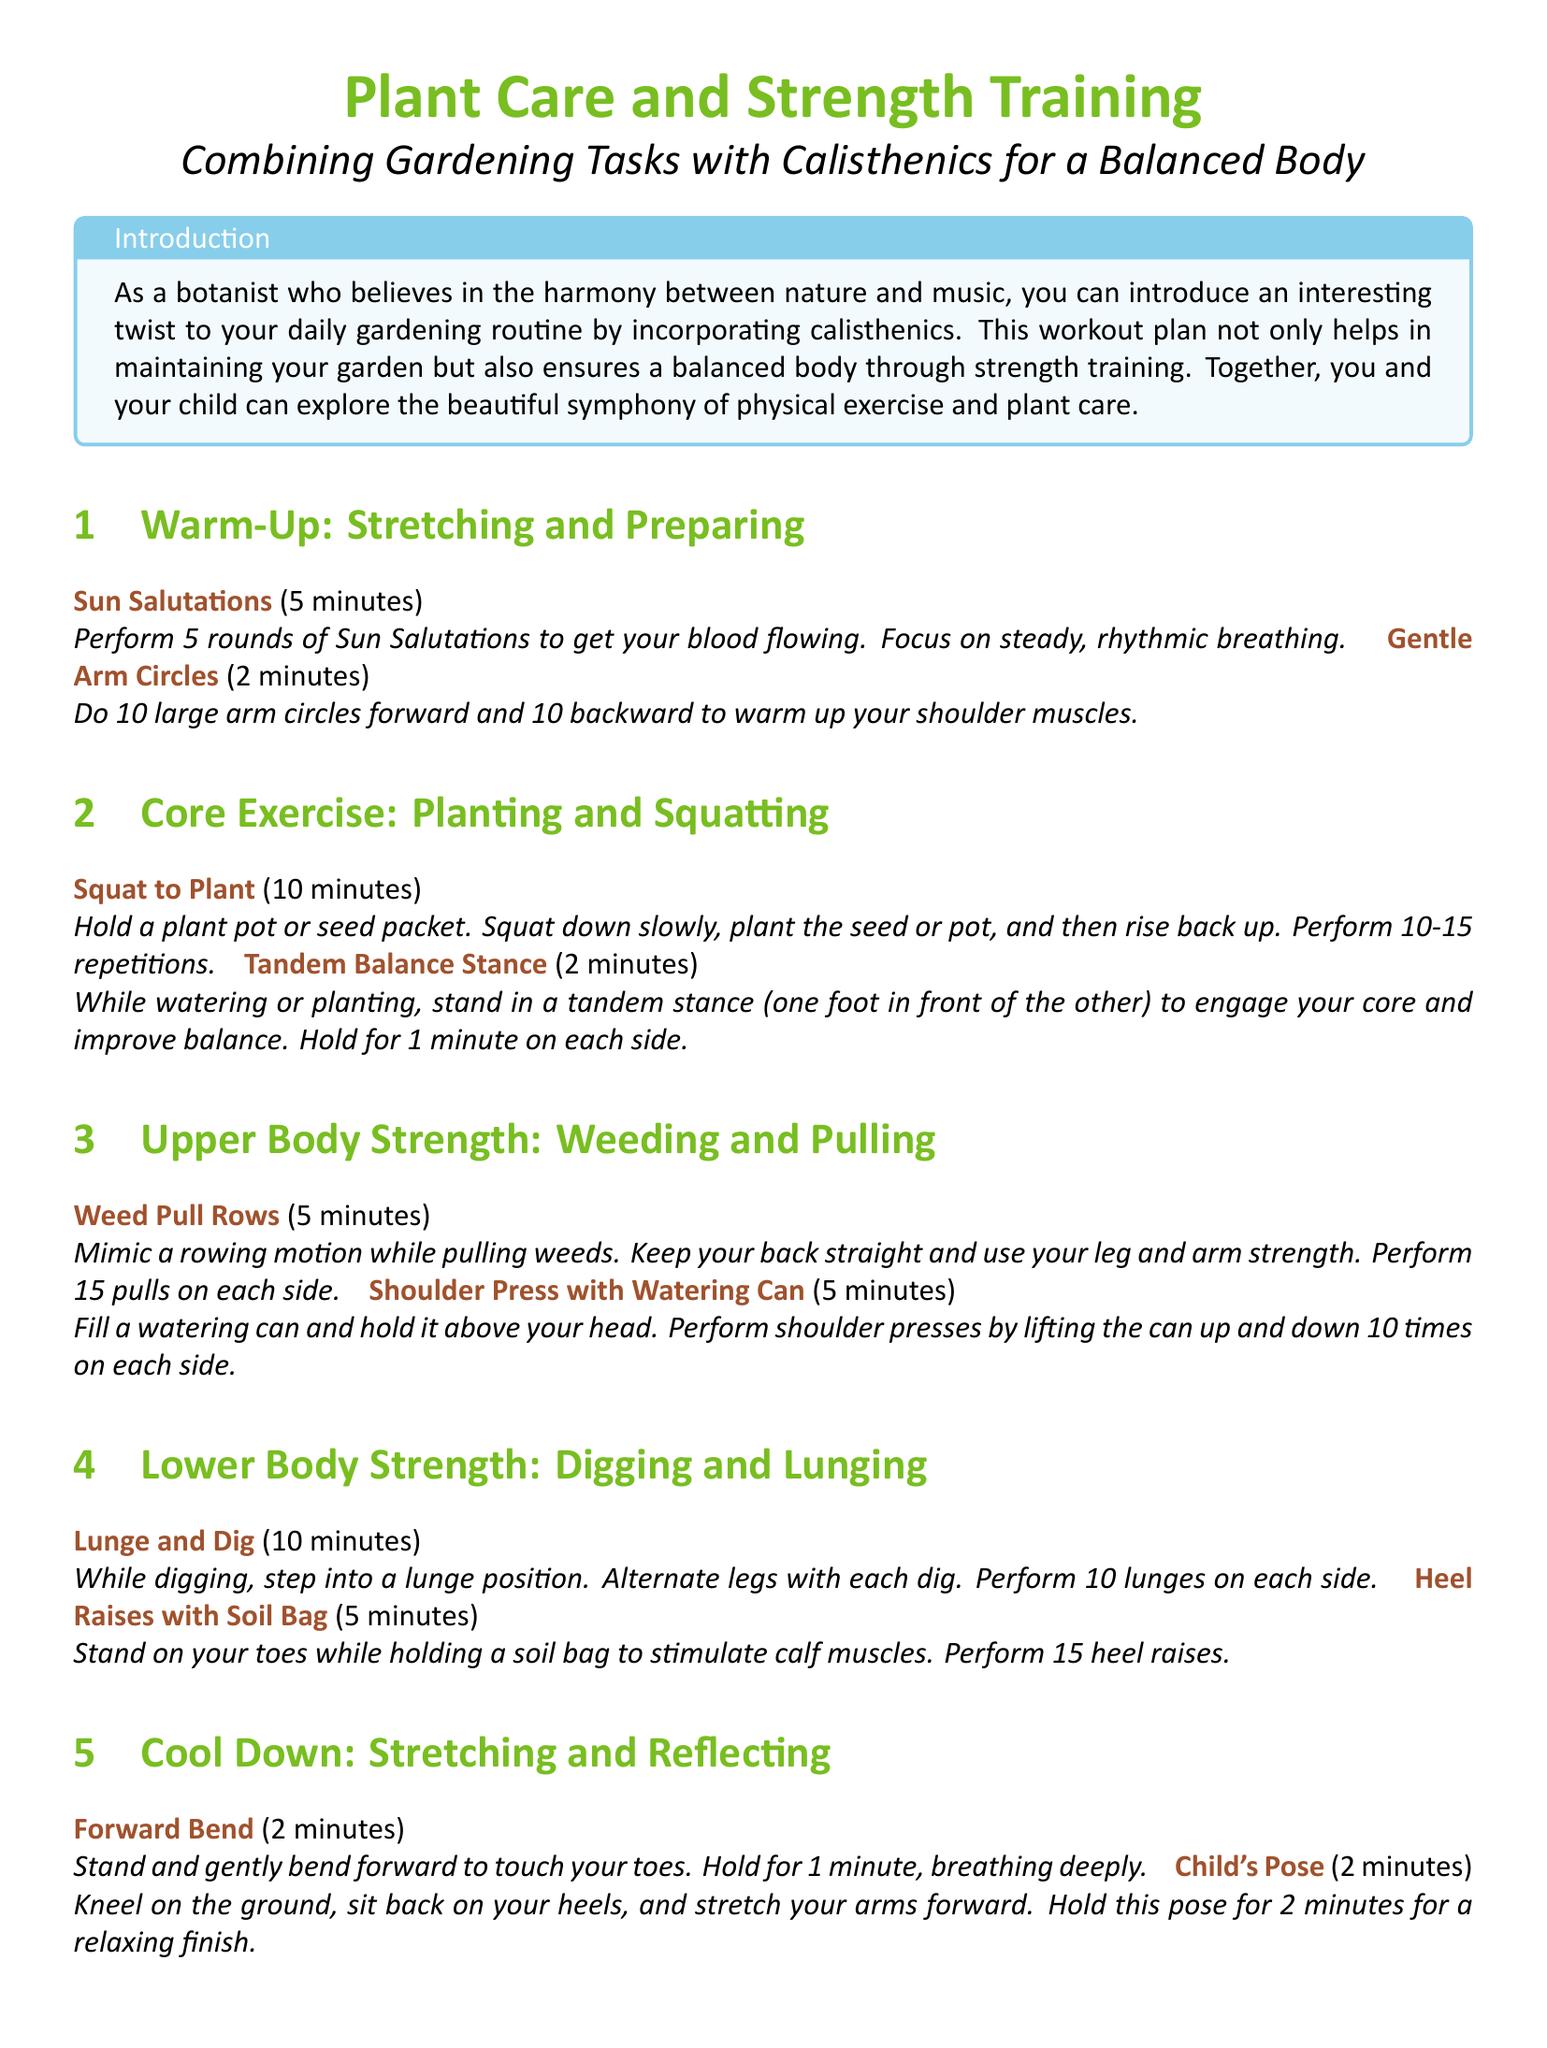what is the title of the document? The title is presented at the top of the document under a large font format.
Answer: Plant Care and Strength Training how many repetitions are suggested for the "Squat to Plant" activity? The number of repetitions is stated in the description of the activity.
Answer: 10-15 what is the total time for the "Core Exercise" section? The time for each activity in the section is added to find the total.
Answer: 12 minutes what is the main focus of the workout plan? The primary emphasis of the workout plan is highlighted in the introduction.
Answer: Harmony between nature and music how many exercises are included in the "Upper Body Strength" section? The document lists the exercises to quantify the total.
Answer: 2 exercises what pose is recommended for the cool down? The final section mentions cool-down activities and specifies one of the poses.
Answer: Child's Pose 